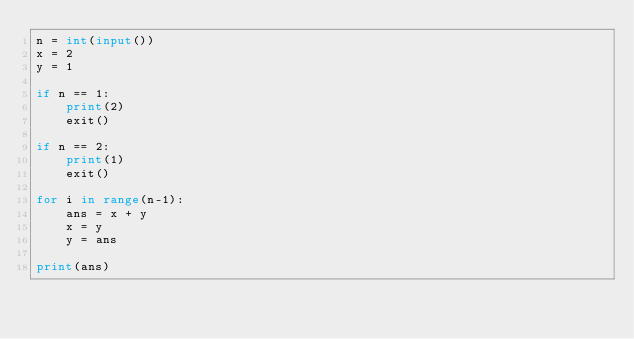Convert code to text. <code><loc_0><loc_0><loc_500><loc_500><_Python_>n = int(input())
x = 2
y = 1

if n == 1:
    print(2)
    exit()

if n == 2:
    print(1)
    exit()

for i in range(n-1):
    ans = x + y
    x = y
    y = ans

print(ans)</code> 